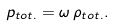Convert formula to latex. <formula><loc_0><loc_0><loc_500><loc_500>p _ { t o t . } = \omega \, \rho _ { t o t . } .</formula> 